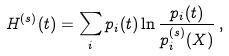<formula> <loc_0><loc_0><loc_500><loc_500>H ^ { ( s ) } ( t ) = \sum _ { i } p _ { i } ( t ) \ln \frac { p _ { i } ( t ) } { p _ { i } ^ { ( s ) } ( X ) } \, ,</formula> 